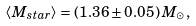<formula> <loc_0><loc_0><loc_500><loc_500>\langle M _ { s t a r } \rangle = \left ( 1 . 3 6 \pm 0 . 0 5 \right ) M _ { \odot } ,</formula> 